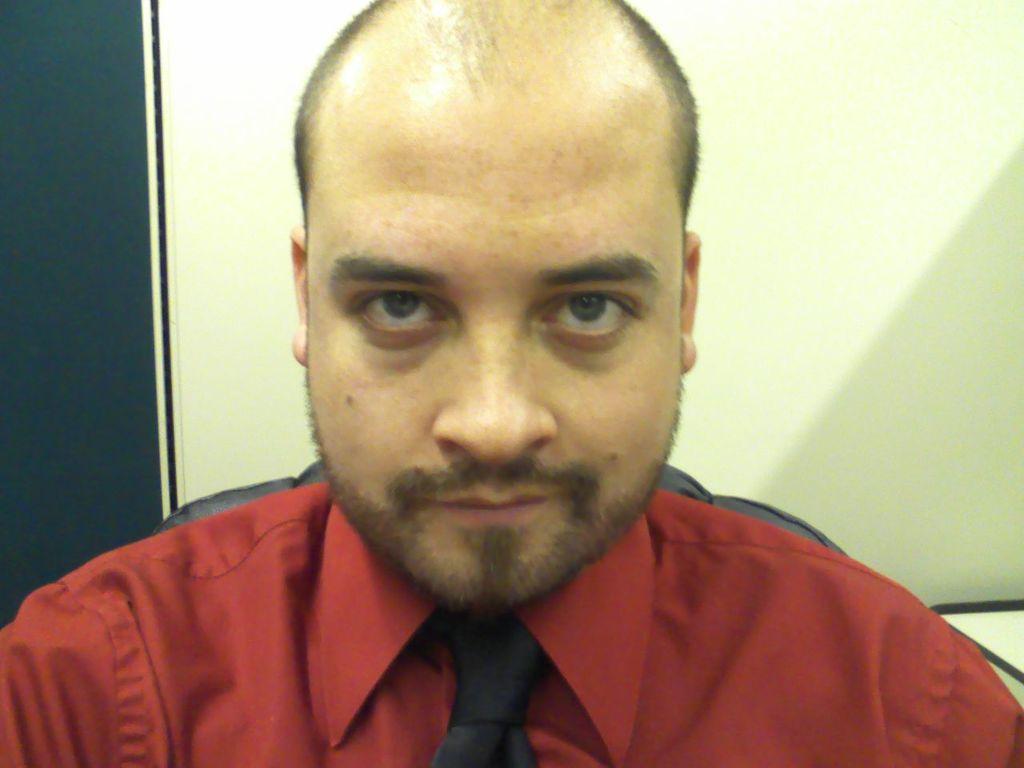In one or two sentences, can you explain what this image depicts? In this image there is a man sitting in chair wearing red shirt and tie, behind him there is a wall. 